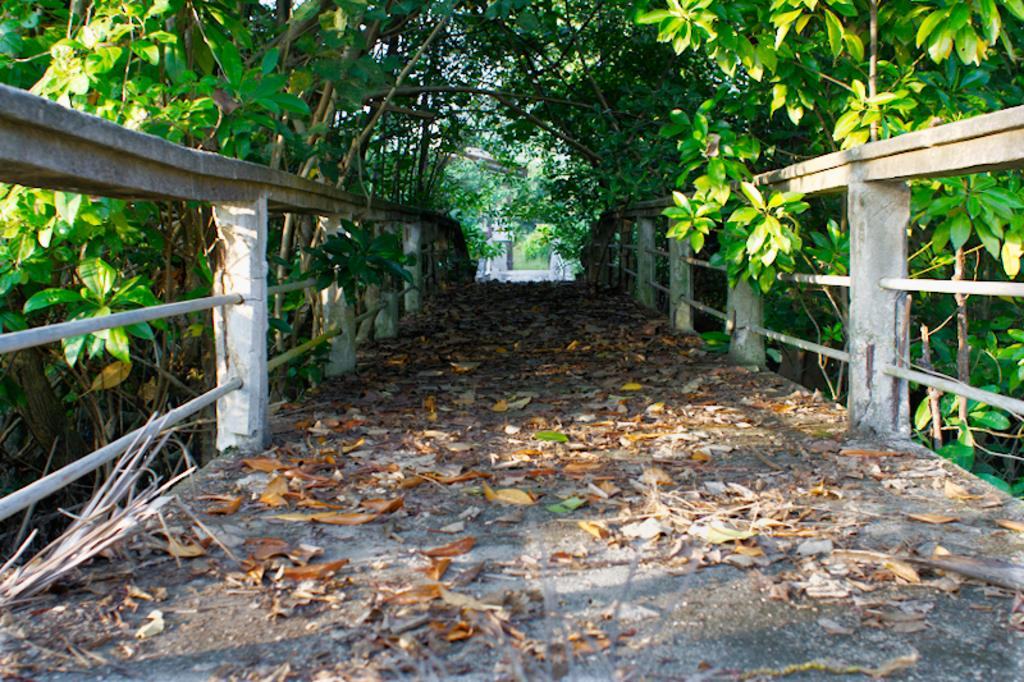What structure can be seen in the image? There is a bridge in the image. What is on the bridge? Dried leaves are present on the bridge. What can be seen on either side of the bridge? There are trees on either side of the bridge. Can you see a stamp on the bridge in the image? There is no stamp present on the bridge in the image. 